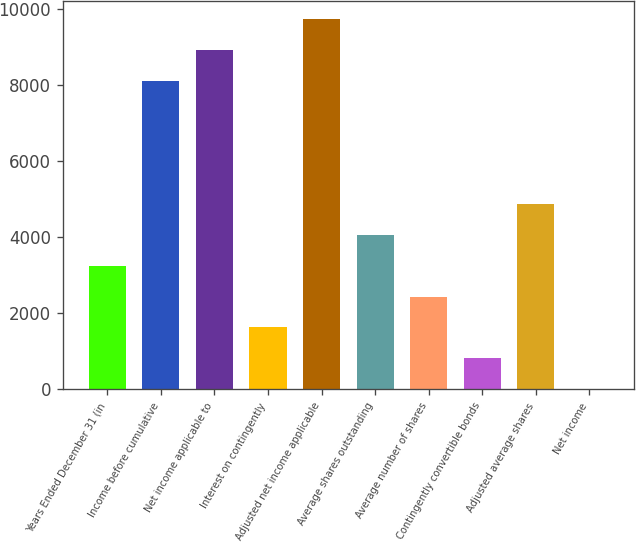Convert chart. <chart><loc_0><loc_0><loc_500><loc_500><bar_chart><fcel>Years Ended December 31 (in<fcel>Income before cumulative<fcel>Net income applicable to<fcel>Interest on contingently<fcel>Adjusted net income applicable<fcel>Average shares outstanding<fcel>Average number of shares<fcel>Contingently convertible bonds<fcel>Adjusted average shares<fcel>Net income<nl><fcel>3249.46<fcel>8099<fcel>8910.59<fcel>1626.28<fcel>9722.18<fcel>4061.05<fcel>2437.87<fcel>814.69<fcel>4872.64<fcel>3.1<nl></chart> 